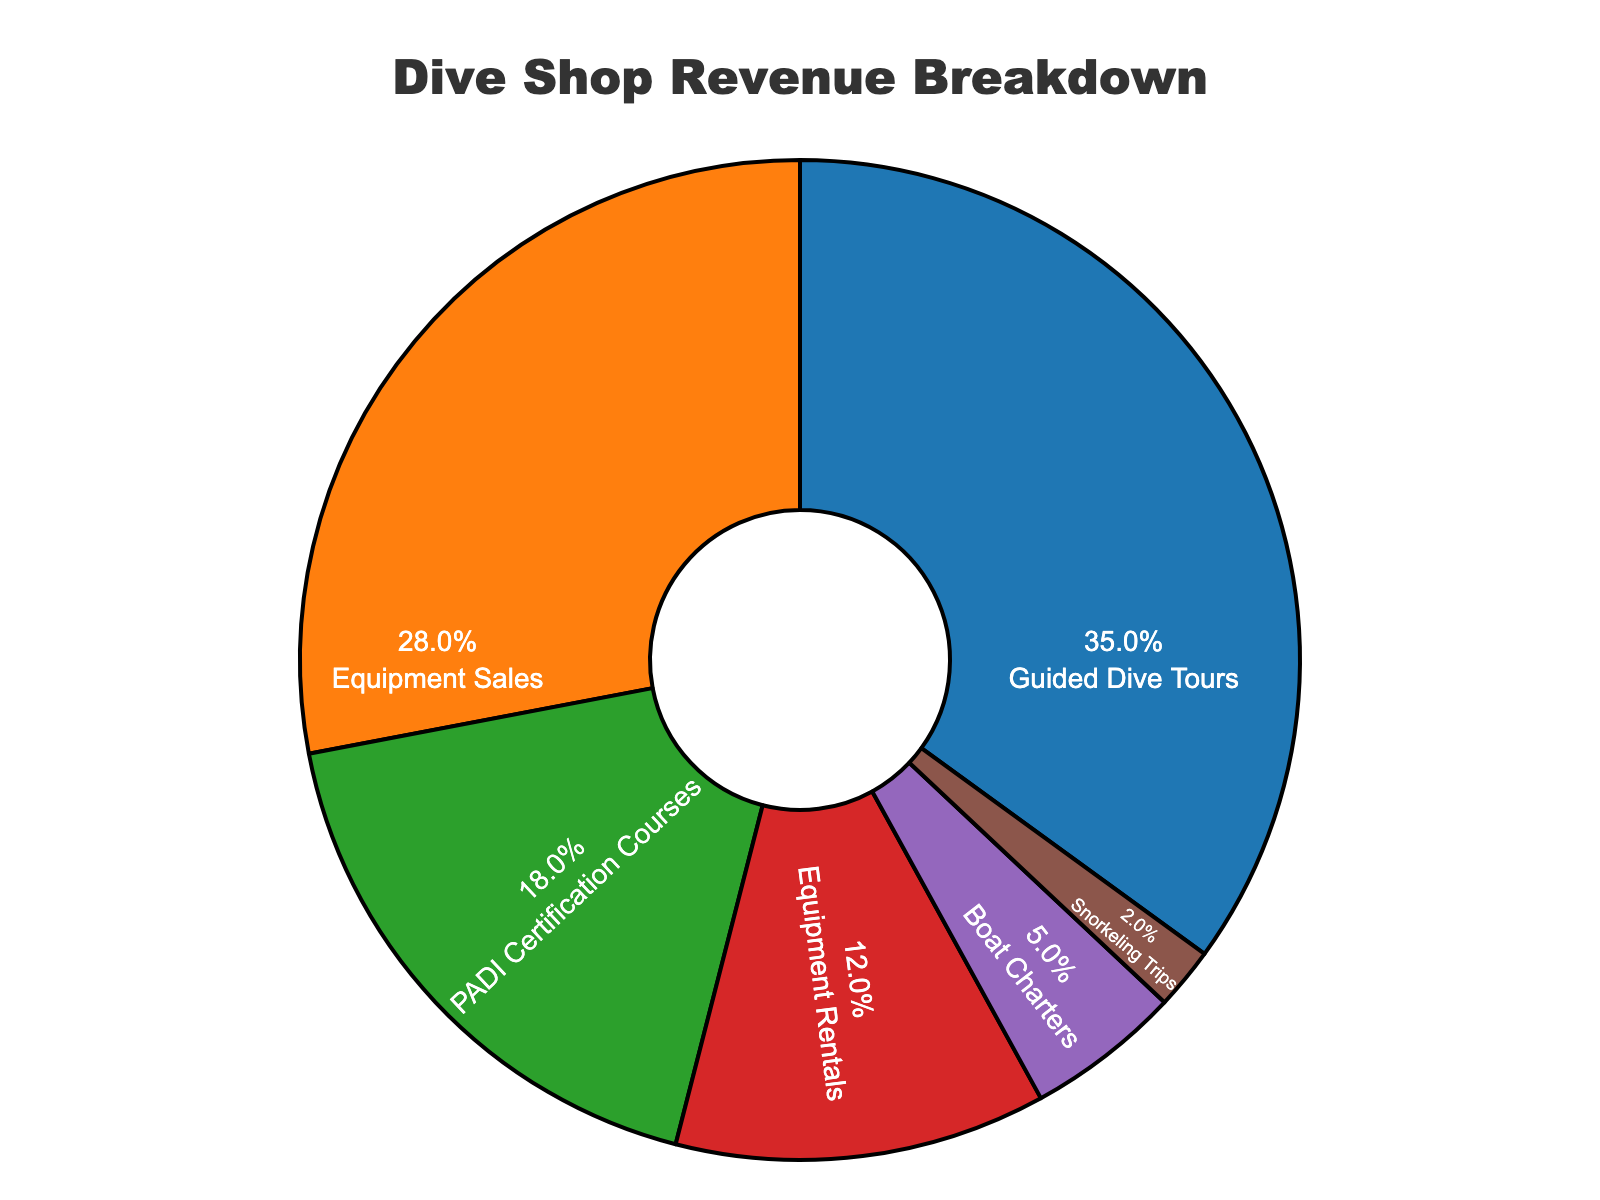What is the largest revenue source for the dive shop? The largest revenue source is the segment with the highest percentage. Guided Dive Tours occupies 35% of the chart, making it the largest source.
Answer: Guided Dive Tours Which revenue source has the smallest percentage? To determine the smallest revenue source, look at the segment with the lowest percentage. The smallest slice of the pie chart is for Snorkeling Trips at 2%.
Answer: Snorkeling Trips What is the combined percentage of Equipment Sales and Equipment Rentals? Add the percentages for Equipment Sales (28%) and Equipment Rentals (12%) to find the combined percentage. 28% + 12% = 40%.
Answer: 40% How much more revenue does Guided Dive Tours generate compared to Boat Charters? Subtract the percentage of Boat Charters (5%) from the percentage of Guided Dive Tours (35%). 35% - 5% = 30%.
Answer: 30% Are Equipment Rentals contributing more or less than PADI Certification Courses to the total revenue? Compare the percentages of Equipment Rentals (12%) and PADI Certification Courses (18%). Equipment Rentals contribute less than PADI Certification Courses.
Answer: Less Which revenue source(s) collectively make up more than half of the revenue? Sum the percentages of the sources until the total exceeds 50%. Guided Dive Tours (35%) + Equipment Sales (28%) = 63%. These two sources collectively make up more than half of the revenue.
Answer: Guided Dive Tours and Equipment Sales If we combine Boat Charters and Snorkeling Trips, would their total revenue percentage be higher or lower than that of PADI Certification Courses? Add the percentages for Boat Charters (5%) and Snorkeling Trips (2%) and compare with PADI Certification Courses (18%). 5% + 2% = 7%, which is lower than 18%.
Answer: Lower How many percentage points of revenue come from the sales-related sources (Equipment Sales and PADI Certification Courses)? Sum the percentages for these two categories: Equipment Sales (28%) and PADI Certification Courses (18%). 28% + 18% = 46%.
Answer: 46% What percentage of the revenue is generated by activities that use boats (Guided Dive Tours, Boat Charters, and Snorkeling Trips)? Sum the percentages for Guided Dive Tours (35%), Boat Charters (5%), and Snorkeling Trips (2%). 35% + 5% + 2% = 42%.
Answer: 42% Calculate the average percentage for all the revenue sources displayed. Sum all the percentages: (35 + 28 + 18 + 12 + 5 + 2 = 100), then divide by the number of sources (6). 100 / 6 = 16.67%.
Answer: 16.67% 